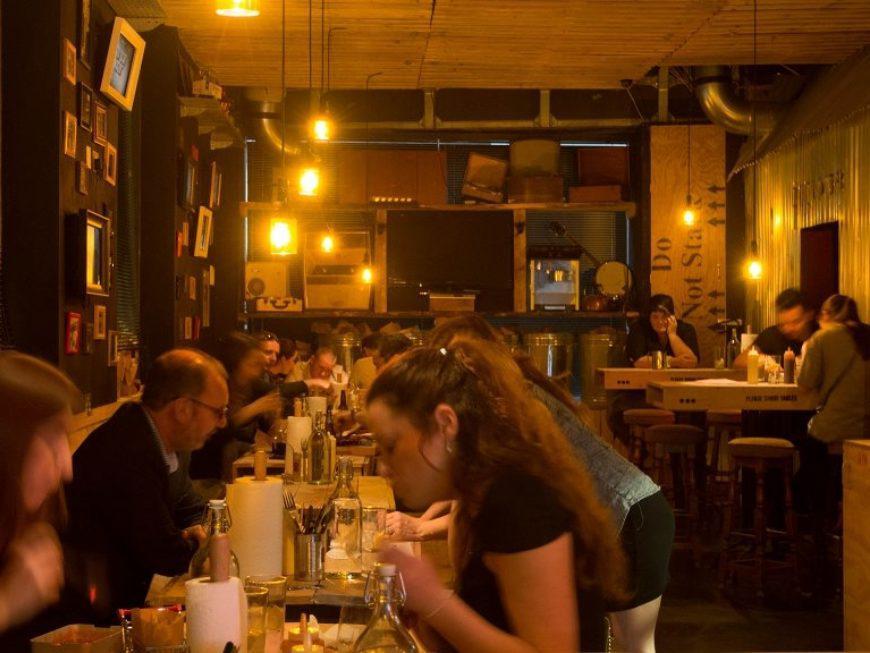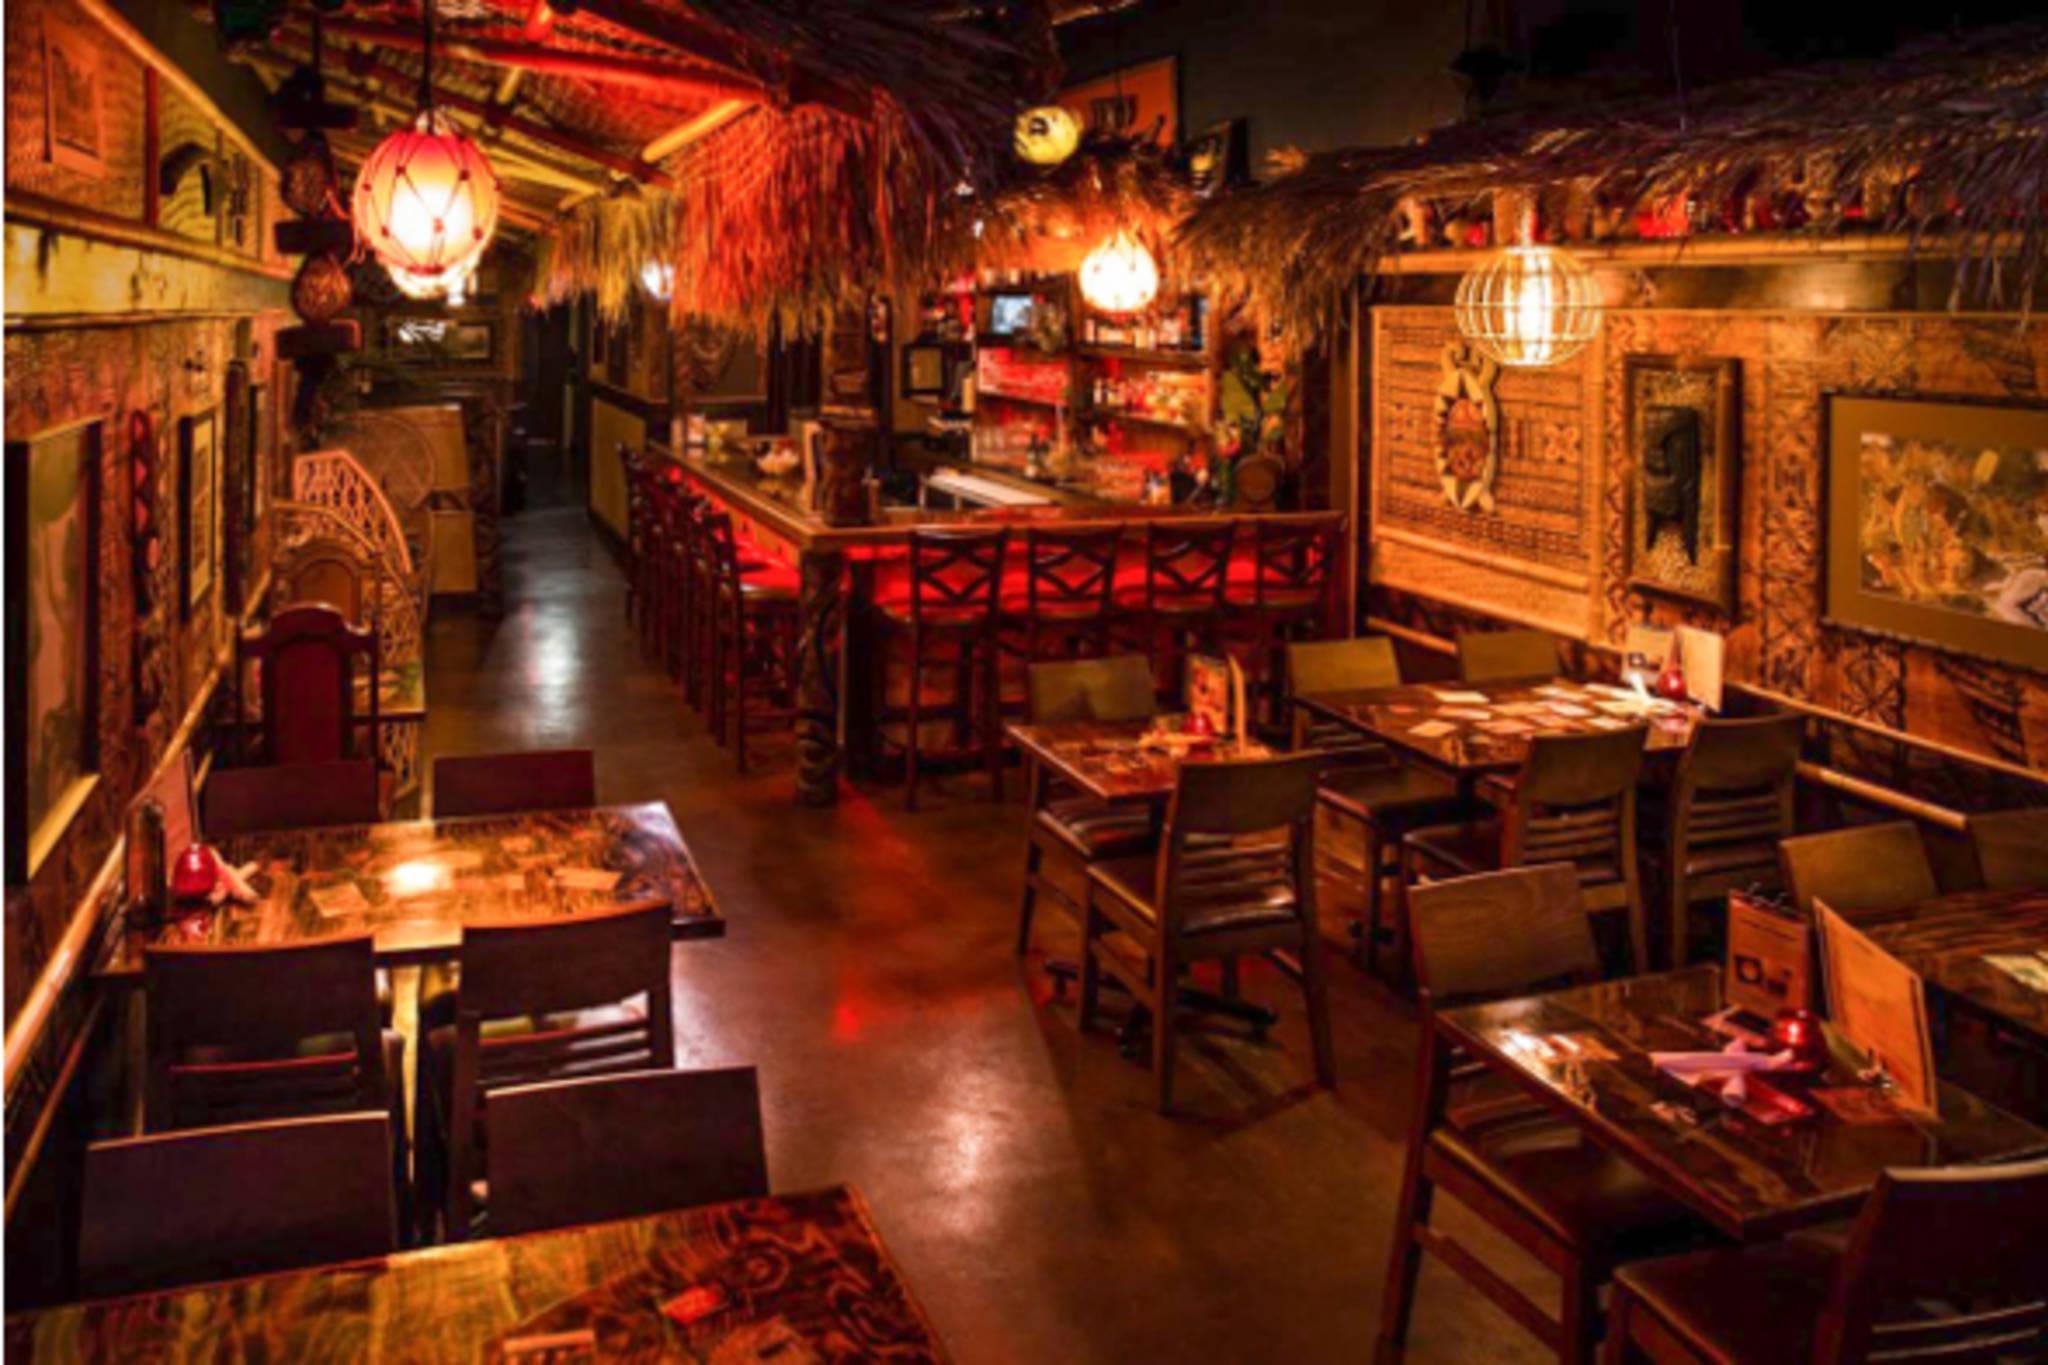The first image is the image on the left, the second image is the image on the right. Examine the images to the left and right. Is the description "In the right image, there's an empty restaurant." accurate? Answer yes or no. Yes. The first image is the image on the left, the second image is the image on the right. For the images shown, is this caption "In the left image, light fixtures with round bottoms suspend over a row of tables with windows to their right, and the restaurant is packed with customers." true? Answer yes or no. No. 